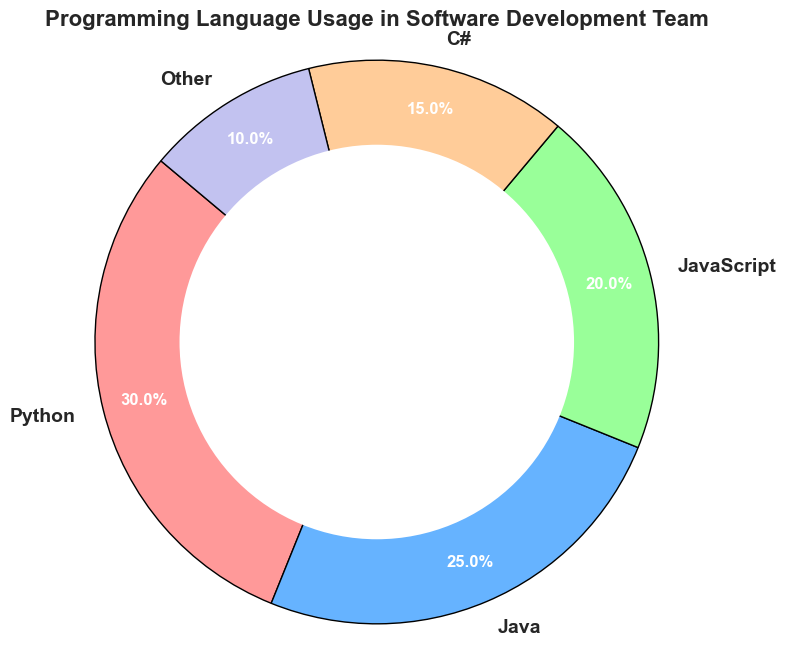What is the most used programming language in the team? To find the most used language, look for the segment with the highest percentage. Python has the largest segment at 30%.
Answer: Python Which programming language is used more, JavaScript or C#? Compare the usage percentages of JavaScript (20%) and C# (15%). JavaScript has a higher usage percentage.
Answer: JavaScript What is the combined usage percentage of Java and C#? Add the usage percentages of Java (25%) and C# (15%). The total is 25% + 15% = 40%.
Answer: 40% How does the usage of Python compare to the usage of Other languages? Python has a usage of 30% while Other languages have 10%. Python is used more than Other languages by a difference of 30% - 10% = 20%.
Answer: Python is used 20% more Which segment is the smallest in the pie chart? Identify the segment with the lowest usage percentage. The segment labeled "Other" has the smallest percentage at 10%.
Answer: Other If the team decides to move 5% from Python to Other, what would the new percentages be for Python and Other? Subtract 5% from Python's current usage (30%) and add it to Other (10%). New usage for Python is 30% - 5% = 25%, and for Other it is 10% + 5% = 15%.
Answer: Python: 25%, Other: 15% Which language has a percentage that is 1.5 times the percentage of C#? First, calculate 1.5 times the percentage of C# (15%). 1.5 * 15% = 22.5%. JavaScript (20%) is the closest to this value but does not match exactly.
Answer: No exact match What percentage of the team uses languages other than Java and JavaScript combined? Subtract the combined usage of Java (25%) and JavaScript (20%) from 100%. 100% - (25% + 20%) = 55%.
Answer: 55% Which programming languages' usage percentages combined make up exactly half of the total usage? Look for languages whose usage percentages add up to 50%. Python (30%) plus JavaScript (20%) equals 30% + 20% = 50%.
Answer: Python and JavaScript 